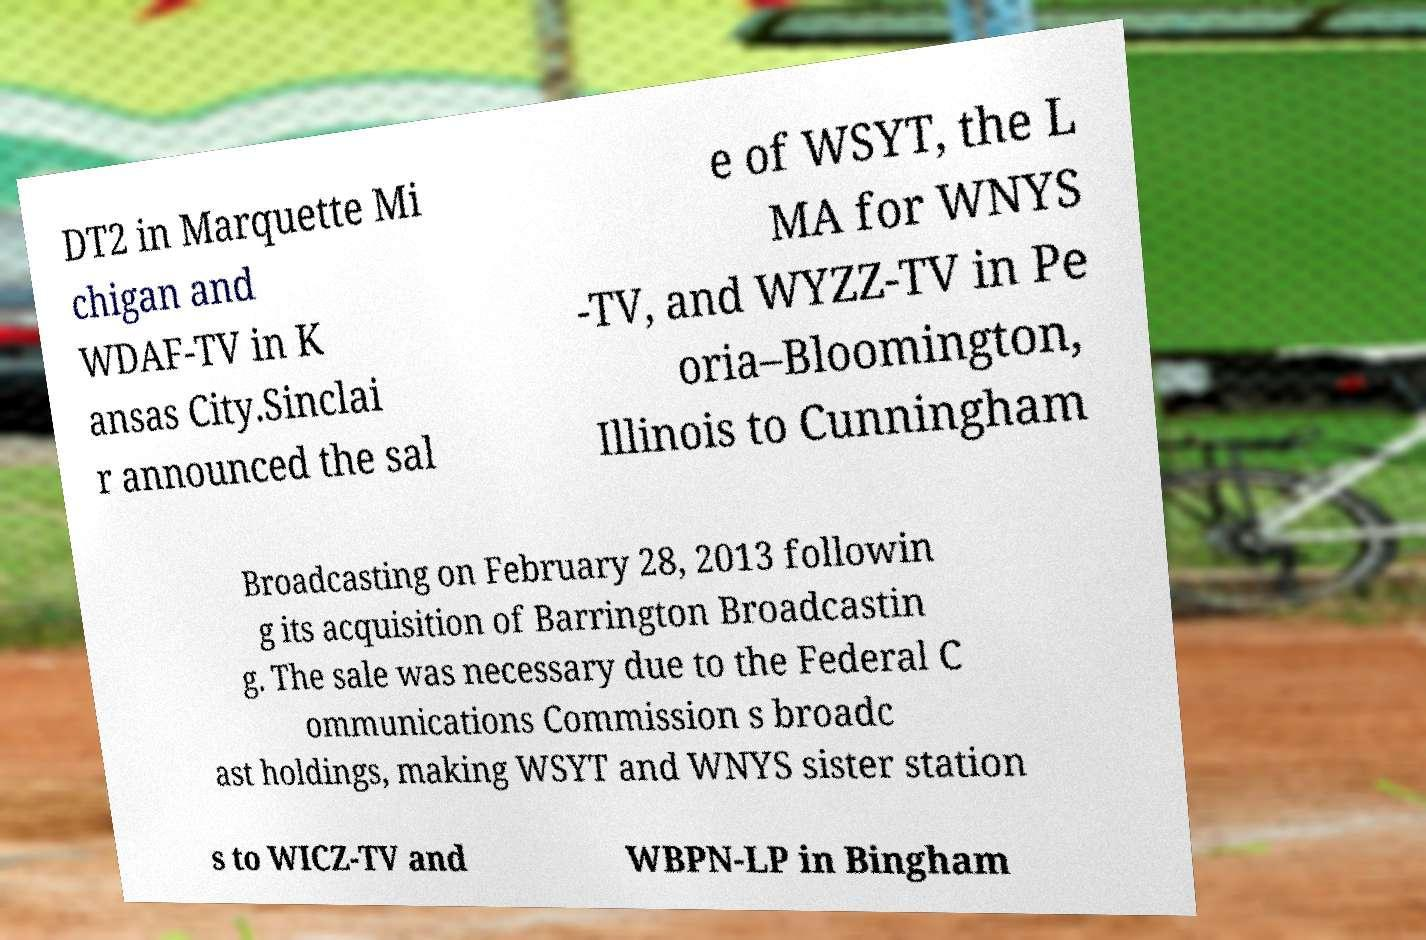Could you assist in decoding the text presented in this image and type it out clearly? DT2 in Marquette Mi chigan and WDAF-TV in K ansas City.Sinclai r announced the sal e of WSYT, the L MA for WNYS -TV, and WYZZ-TV in Pe oria–Bloomington, Illinois to Cunningham Broadcasting on February 28, 2013 followin g its acquisition of Barrington Broadcastin g. The sale was necessary due to the Federal C ommunications Commission s broadc ast holdings, making WSYT and WNYS sister station s to WICZ-TV and WBPN-LP in Bingham 